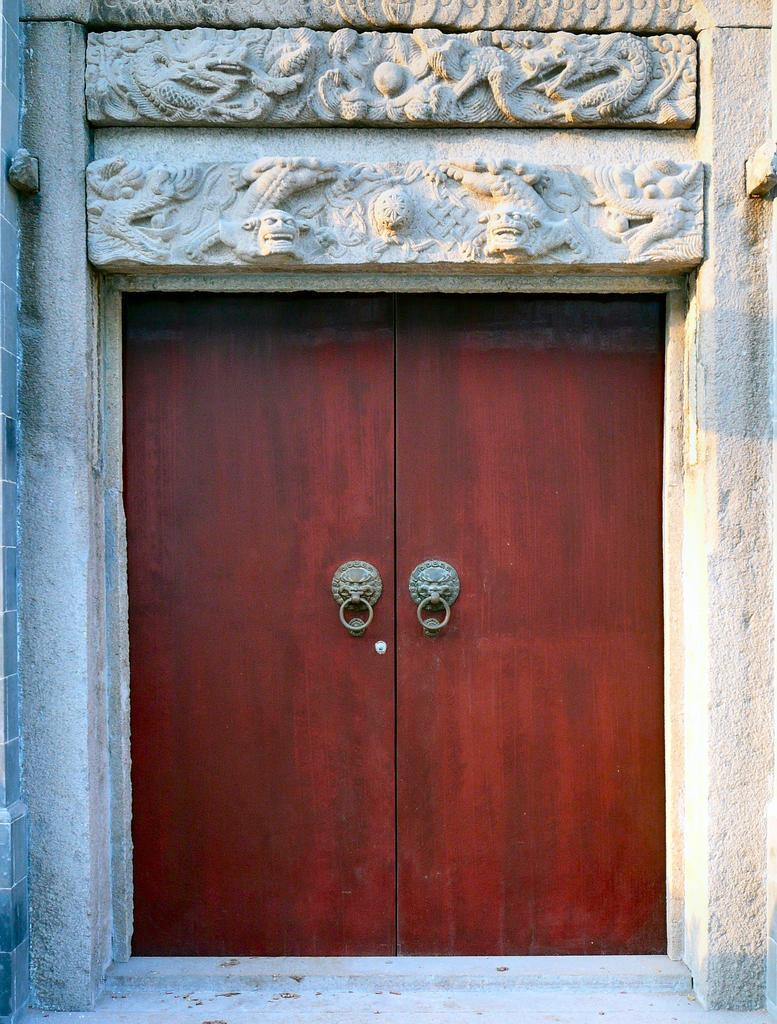What type of door is visible in the image? There is a wooden door in the image. What structure is present in the image? There is a building in the image. What type of decoration or detail can be seen on the building? There is stone carving visible in the image. How does the machine operate in the image? There is no machine present in the image. 